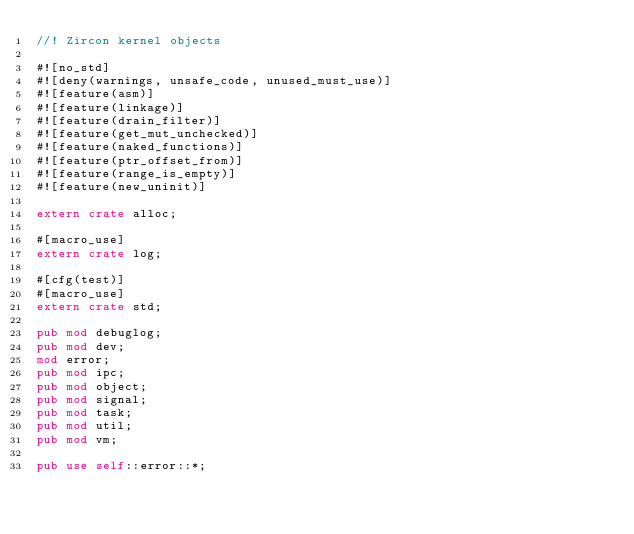<code> <loc_0><loc_0><loc_500><loc_500><_Rust_>//! Zircon kernel objects

#![no_std]
#![deny(warnings, unsafe_code, unused_must_use)]
#![feature(asm)]
#![feature(linkage)]
#![feature(drain_filter)]
#![feature(get_mut_unchecked)]
#![feature(naked_functions)]
#![feature(ptr_offset_from)]
#![feature(range_is_empty)]
#![feature(new_uninit)]

extern crate alloc;

#[macro_use]
extern crate log;

#[cfg(test)]
#[macro_use]
extern crate std;

pub mod debuglog;
pub mod dev;
mod error;
pub mod ipc;
pub mod object;
pub mod signal;
pub mod task;
pub mod util;
pub mod vm;

pub use self::error::*;
</code> 